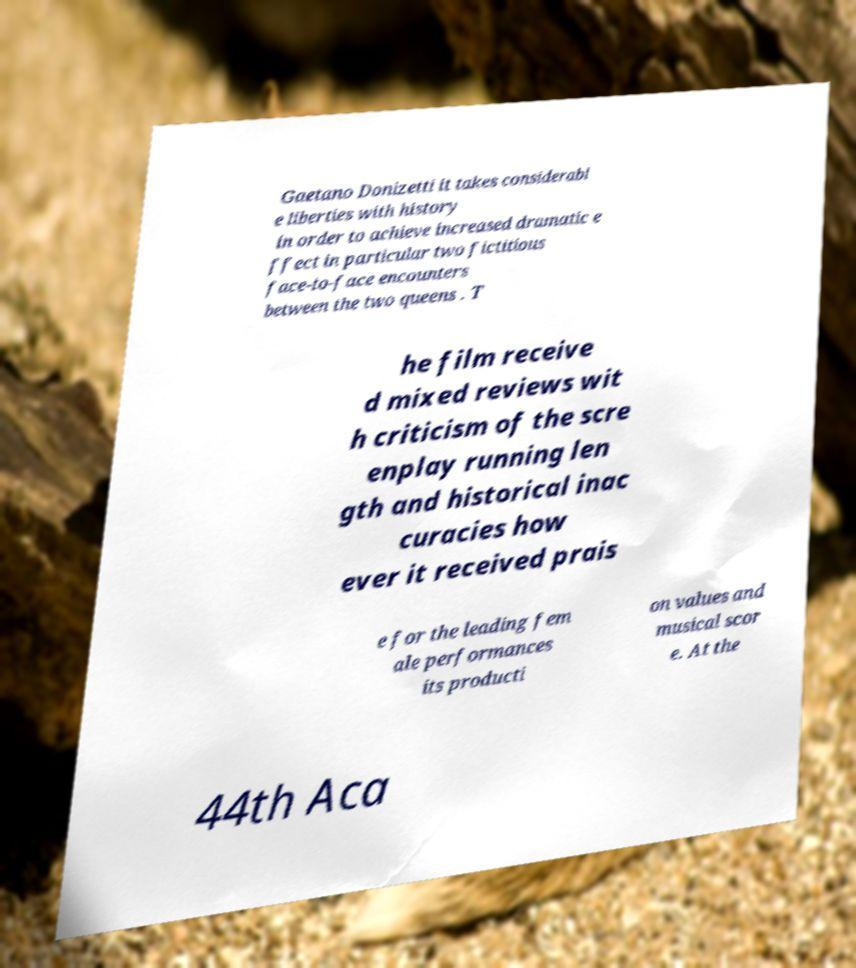Please read and relay the text visible in this image. What does it say? Gaetano Donizetti it takes considerabl e liberties with history in order to achieve increased dramatic e ffect in particular two fictitious face-to-face encounters between the two queens . T he film receive d mixed reviews wit h criticism of the scre enplay running len gth and historical inac curacies how ever it received prais e for the leading fem ale performances its producti on values and musical scor e. At the 44th Aca 